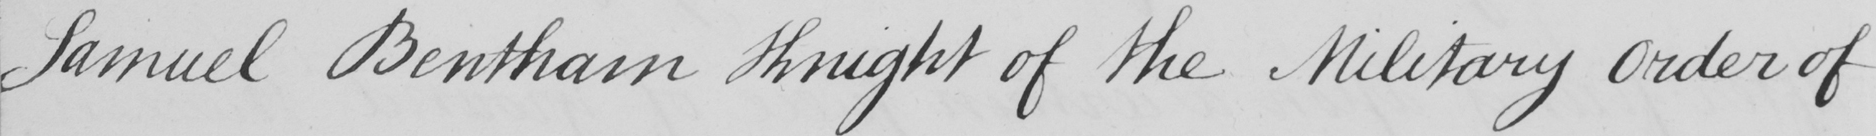Transcribe the text shown in this historical manuscript line. Samuel Bentham Knight of the Military Order of 